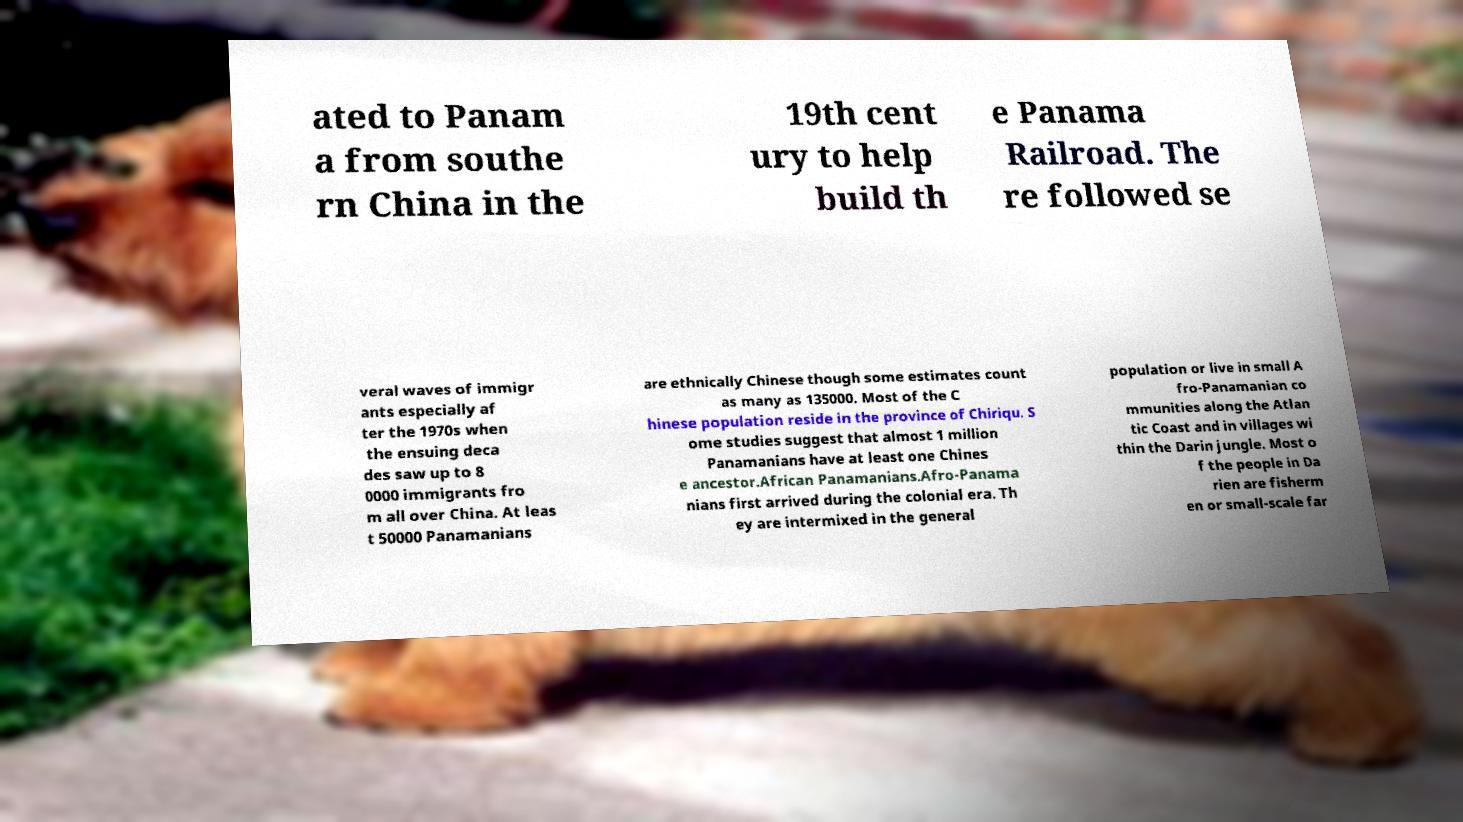Can you read and provide the text displayed in the image?This photo seems to have some interesting text. Can you extract and type it out for me? ated to Panam a from southe rn China in the 19th cent ury to help build th e Panama Railroad. The re followed se veral waves of immigr ants especially af ter the 1970s when the ensuing deca des saw up to 8 0000 immigrants fro m all over China. At leas t 50000 Panamanians are ethnically Chinese though some estimates count as many as 135000. Most of the C hinese population reside in the province of Chiriqu. S ome studies suggest that almost 1 million Panamanians have at least one Chines e ancestor.African Panamanians.Afro-Panama nians first arrived during the colonial era. Th ey are intermixed in the general population or live in small A fro-Panamanian co mmunities along the Atlan tic Coast and in villages wi thin the Darin jungle. Most o f the people in Da rien are fisherm en or small-scale far 